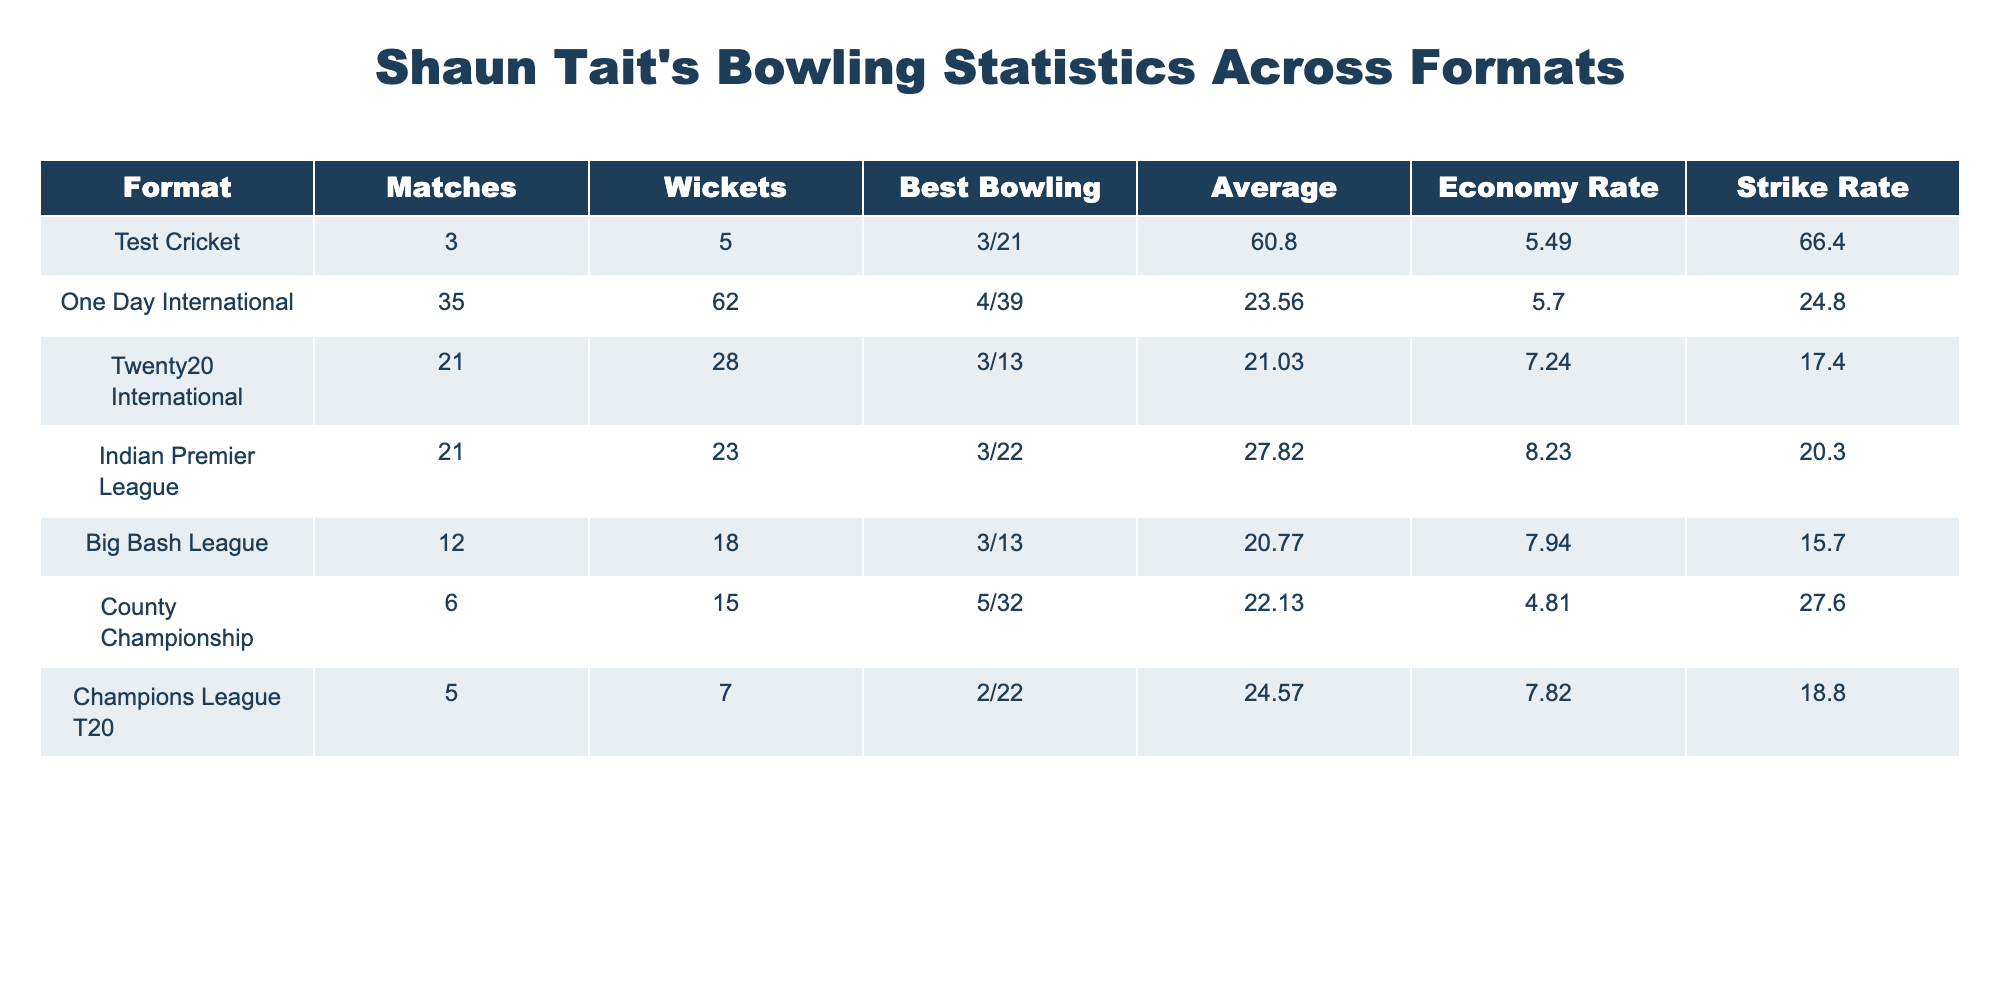What is the best bowling figure of Shaun Tait in Test cricket? Referring to the table, in the Test Cricket format, the best bowling figure is noted as 3/21.
Answer: 3/21 How many wickets did Shaun Tait take in One Day Internationals? According to the table, it states that Shaun Tait took 62 wickets in One Day Internationals.
Answer: 62 What is the average bowling figure of Shaun Tait in Twenty20 Internationals? The average bowling figure for Shaun Tait in Twenty20 Internationals is given as 21.03.
Answer: 21.03 True or False: Shaun Tait has a better economy rate in County Championship compared to Test Cricket. The economy rate in County Championship is 4.81, while in Test Cricket it is 5.49. Since 4.81 is less than 5.49, the statement is indeed true.
Answer: True What is the total number of wickets taken by Shaun Tait in Big Bash League and Indian Premier League combined? In the Big Bash League, he took 18 wickets, and in the Indian Premier League, he took 23 wickets. Adding these gives us a total of 18 + 23 = 41 wickets.
Answer: 41 How does Shaun Tait’s strike rate compare between One Day Internationals and Twenty20 Internationals? The strike rate for One Day Internationals is 24.8, while in Twenty20 Internationals it is 17.4. A lower strike rate indicates better performance, so Tait is more effective in Twenty20 Internationals compared to One Day Internationals.
Answer: He has a lower strike rate in Twenty20 Internationals What is the difference in wickets taken between Tests and T20 Internationals? In Test Cricket, Shaun Tait took 5 wickets, and in T20 Internationals, he took 28 wickets. The difference, therefore, is 28 - 5 = 23 wickets.
Answer: 23 Did Shaun Tait take more wickets in the Indian Premier League or in One Day Internationals? From the data, Tait took 23 wickets in the Indian Premier League and 62 in One Day Internationals. Thus, he took more wickets in One Day Internationals.
Answer: One Day Internationals What is the average for Shaun Tait across all formats combined? To find the average, we combine all the wickets taken across formats and divide by the number of matches played. Total wickets taken are 5 (Tests) + 62 (ODIs) + 28 (T20Is) + 23 (IPL) + 18 (BBL) + 15 (County) + 7 (CL T20) = 158 wickets. Total matches = 3 + 35 + 21 + 21 + 12 + 6 + 5 = 103. Therefore, Average = 158 / 103 = 1.53 wickets per match.
Answer: 1.53 